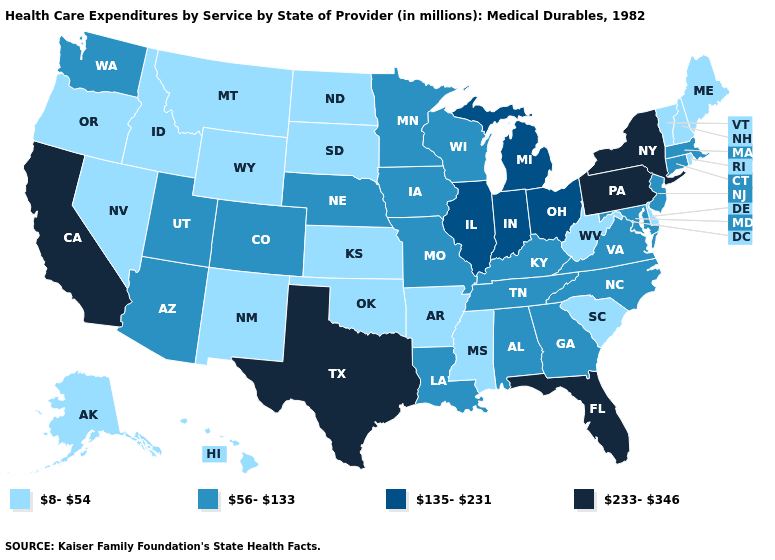Does the first symbol in the legend represent the smallest category?
Give a very brief answer. Yes. Does the map have missing data?
Give a very brief answer. No. Name the states that have a value in the range 8-54?
Keep it brief. Alaska, Arkansas, Delaware, Hawaii, Idaho, Kansas, Maine, Mississippi, Montana, Nevada, New Hampshire, New Mexico, North Dakota, Oklahoma, Oregon, Rhode Island, South Carolina, South Dakota, Vermont, West Virginia, Wyoming. Does California have the highest value in the West?
Short answer required. Yes. Among the states that border Illinois , which have the lowest value?
Short answer required. Iowa, Kentucky, Missouri, Wisconsin. Name the states that have a value in the range 56-133?
Answer briefly. Alabama, Arizona, Colorado, Connecticut, Georgia, Iowa, Kentucky, Louisiana, Maryland, Massachusetts, Minnesota, Missouri, Nebraska, New Jersey, North Carolina, Tennessee, Utah, Virginia, Washington, Wisconsin. What is the value of Maine?
Be succinct. 8-54. Does the map have missing data?
Give a very brief answer. No. Among the states that border Minnesota , which have the lowest value?
Be succinct. North Dakota, South Dakota. What is the value of Alabama?
Quick response, please. 56-133. What is the lowest value in the USA?
Write a very short answer. 8-54. How many symbols are there in the legend?
Be succinct. 4. Name the states that have a value in the range 233-346?
Answer briefly. California, Florida, New York, Pennsylvania, Texas. Which states hav the highest value in the West?
Give a very brief answer. California. What is the value of South Carolina?
Give a very brief answer. 8-54. 